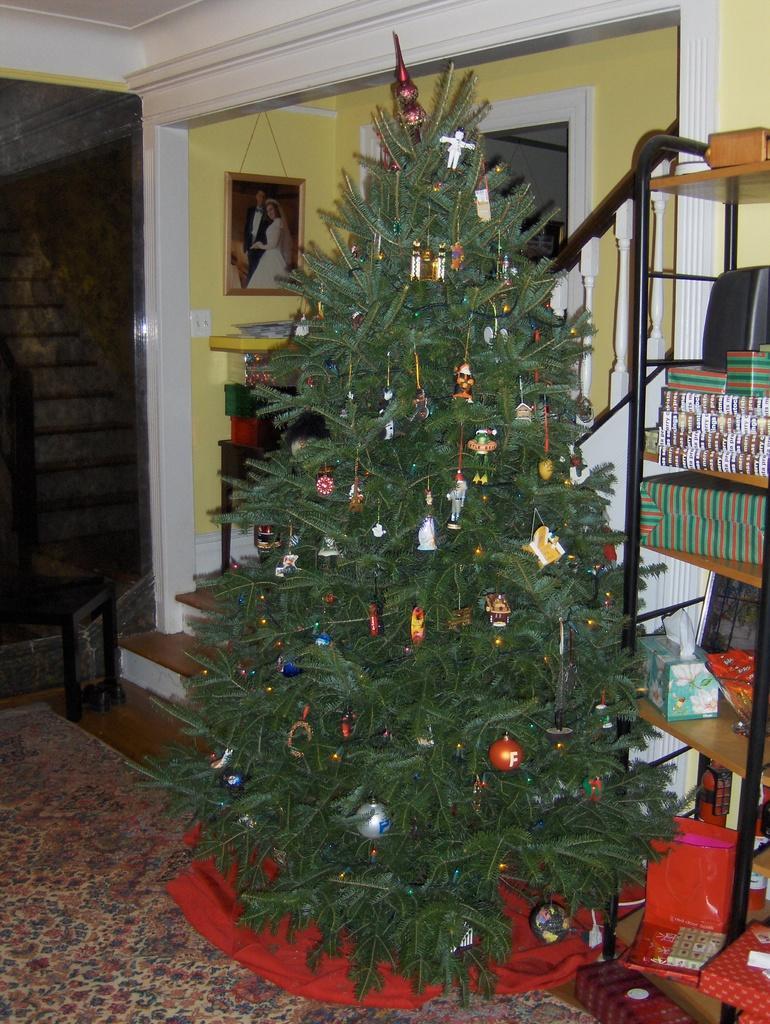Could you give a brief overview of what you see in this image? In this image we can see the inner view of a room and there is a Christmas tree with some decorative items and on the right side we can see a rack with some gifts and other objects. In the background, we can see the wall with a photo frame and there are some things on the floor. 